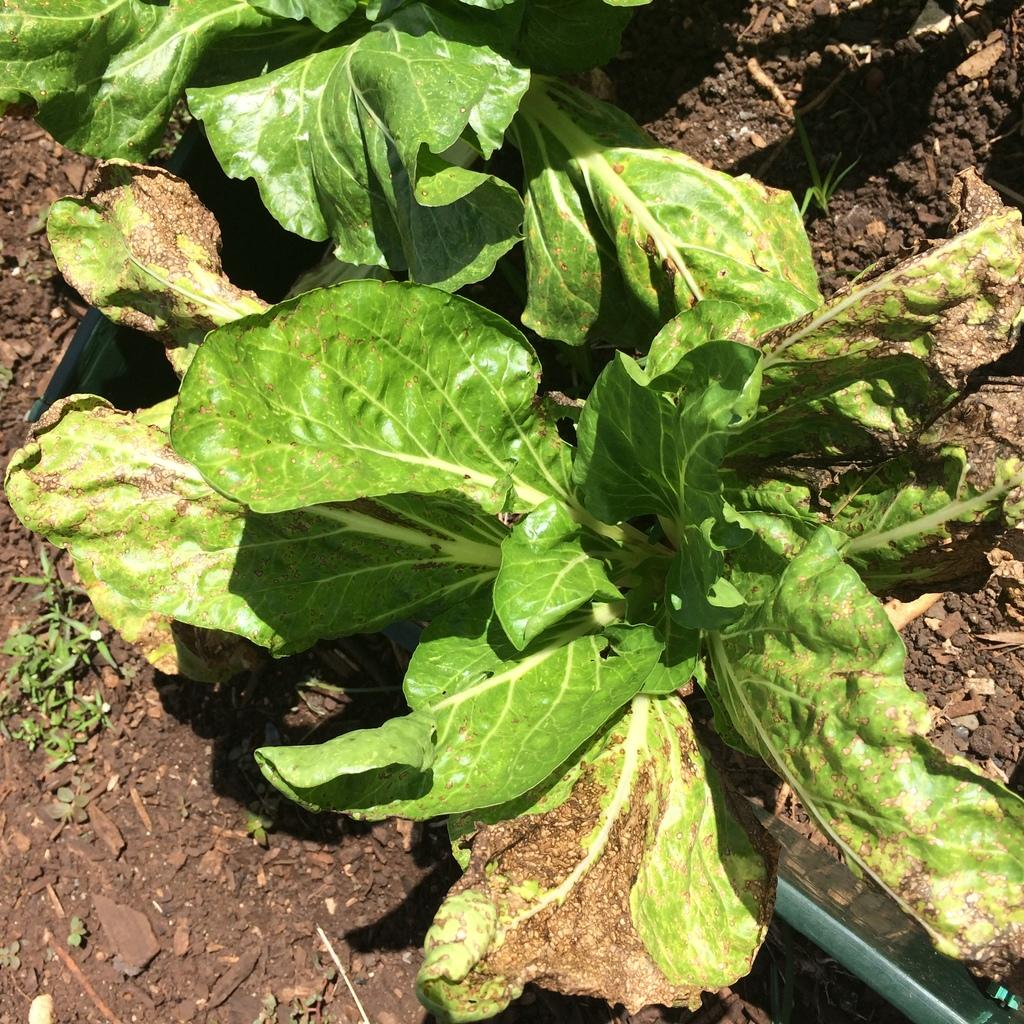What type of vegetation can be seen in the image? There are leaves in the image. Can you describe the condition of some of the leaves? Some of the leaves are damaged. What is the base material visible in the image? There is soil visible in the image. What date is marked on the calendar in the image? There is no calendar present in the image. What type of rhythm can be heard from the leaves in the image? The leaves in the image are not making any sound, so there is no rhythm to be heard. 